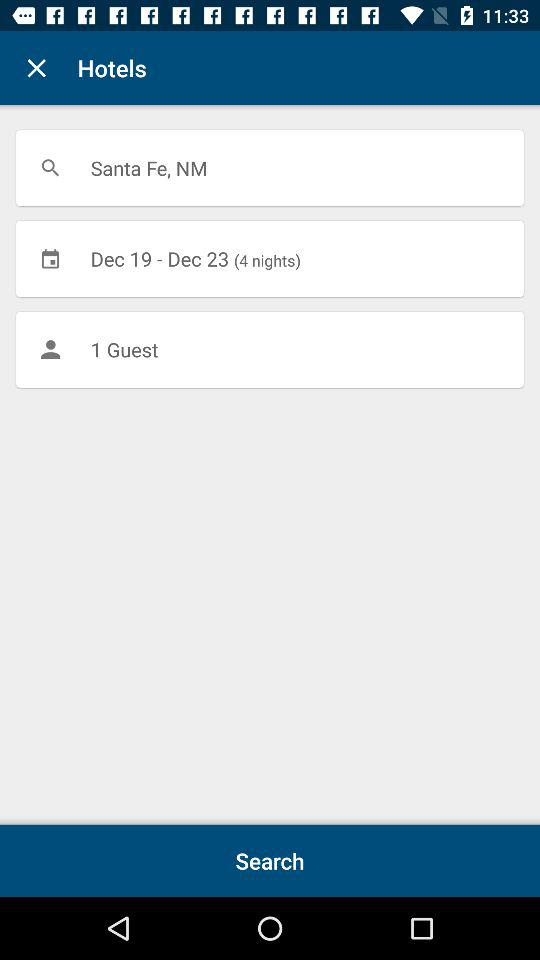How many more days are there until the end of the search?
Answer the question using a single word or phrase. 4 